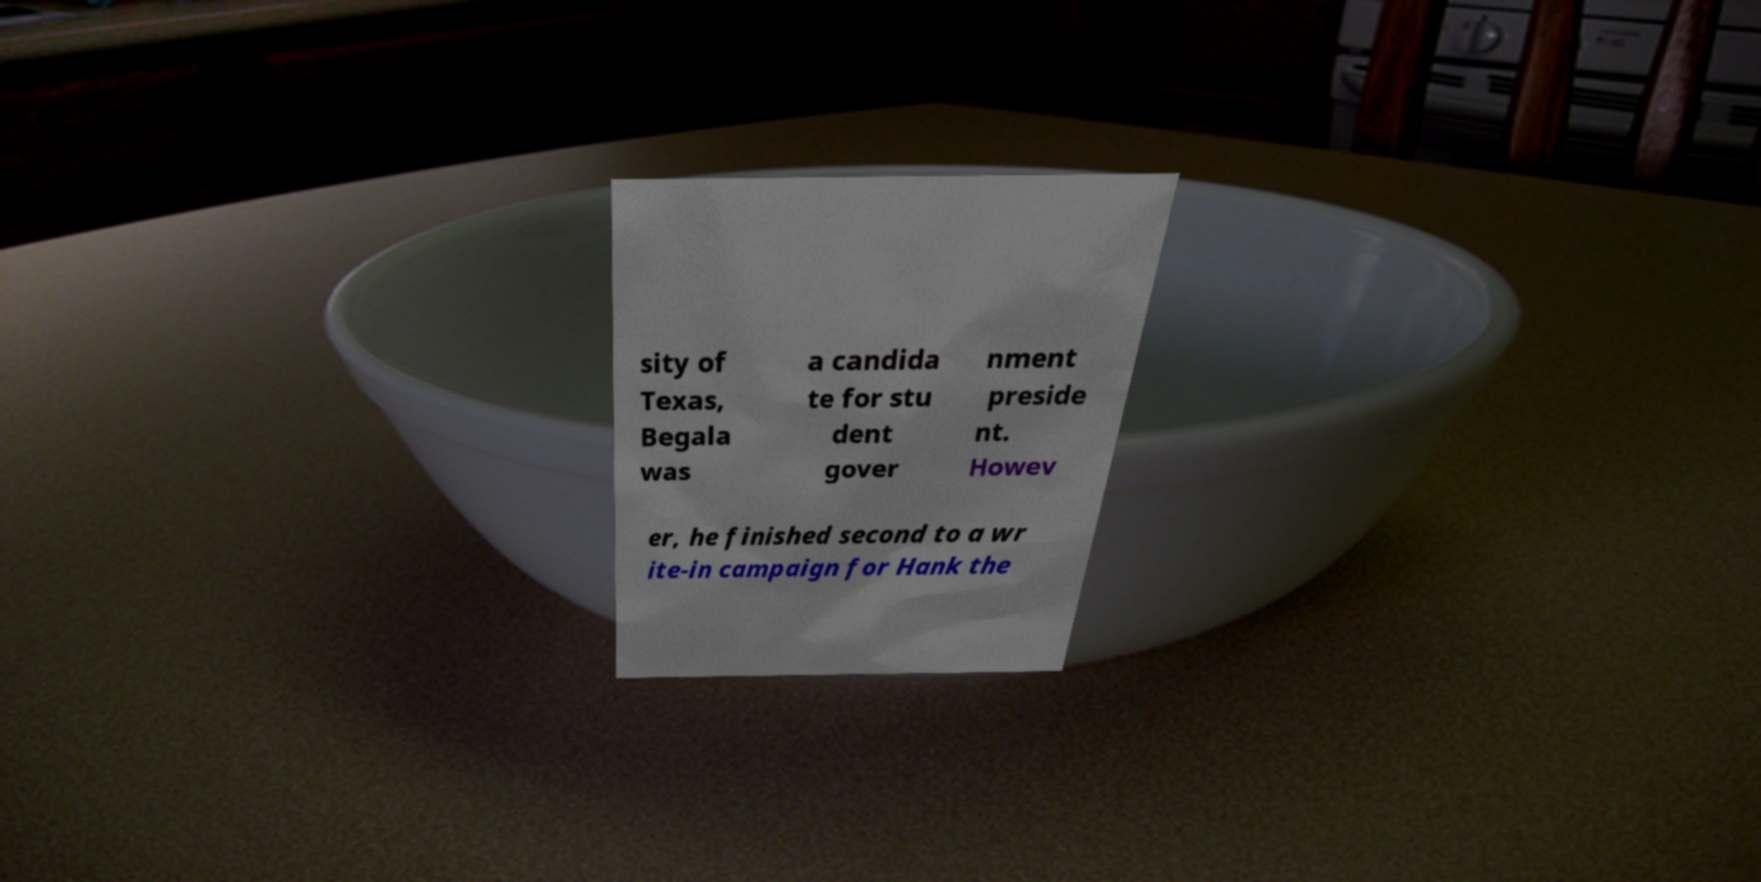There's text embedded in this image that I need extracted. Can you transcribe it verbatim? sity of Texas, Begala was a candida te for stu dent gover nment preside nt. Howev er, he finished second to a wr ite-in campaign for Hank the 